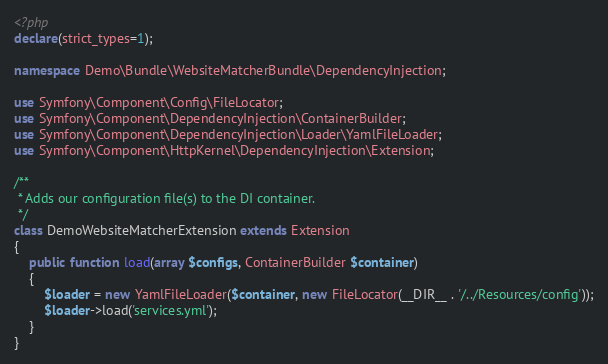Convert code to text. <code><loc_0><loc_0><loc_500><loc_500><_PHP_><?php
declare(strict_types=1);

namespace Demo\Bundle\WebsiteMatcherBundle\DependencyInjection;

use Symfony\Component\Config\FileLocator;
use Symfony\Component\DependencyInjection\ContainerBuilder;
use Symfony\Component\DependencyInjection\Loader\YamlFileLoader;
use Symfony\Component\HttpKernel\DependencyInjection\Extension;

/**
 * Adds our configuration file(s) to the DI container.
 */
class DemoWebsiteMatcherExtension extends Extension
{
    public function load(array $configs, ContainerBuilder $container)
    {
        $loader = new YamlFileLoader($container, new FileLocator(__DIR__ . '/../Resources/config'));
        $loader->load('services.yml');
    }
}
</code> 